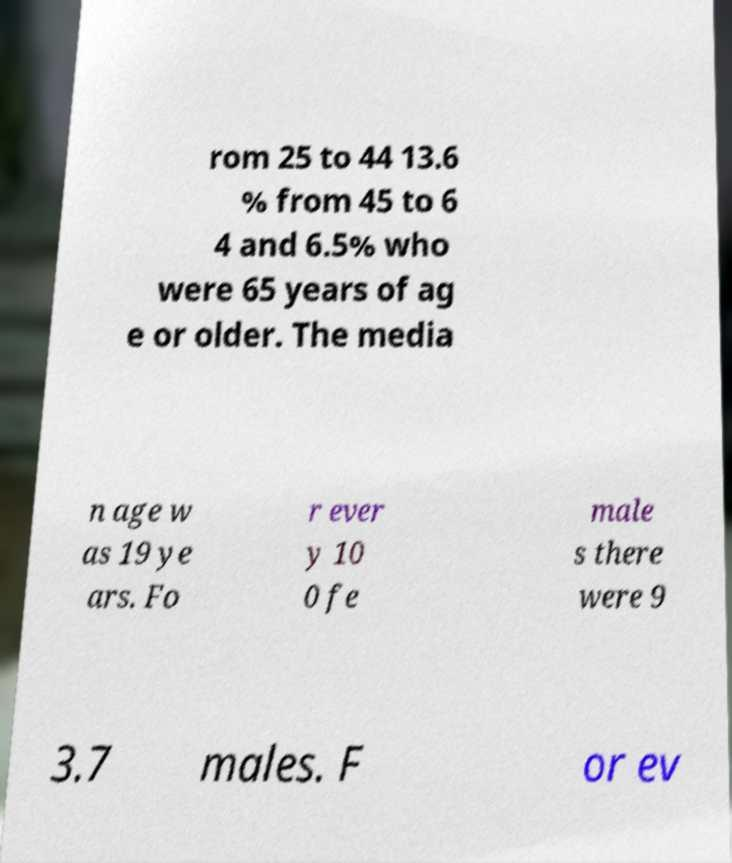I need the written content from this picture converted into text. Can you do that? rom 25 to 44 13.6 % from 45 to 6 4 and 6.5% who were 65 years of ag e or older. The media n age w as 19 ye ars. Fo r ever y 10 0 fe male s there were 9 3.7 males. F or ev 